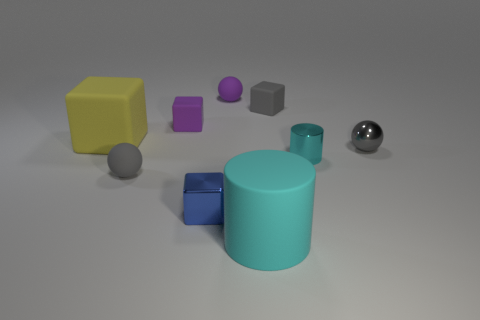Subtract all gray spheres. How many were subtracted if there are1gray spheres left? 1 Subtract all cylinders. How many objects are left? 7 Subtract all big brown rubber things. Subtract all gray things. How many objects are left? 6 Add 7 small cyan cylinders. How many small cyan cylinders are left? 8 Add 8 purple cubes. How many purple cubes exist? 9 Subtract 2 gray balls. How many objects are left? 7 